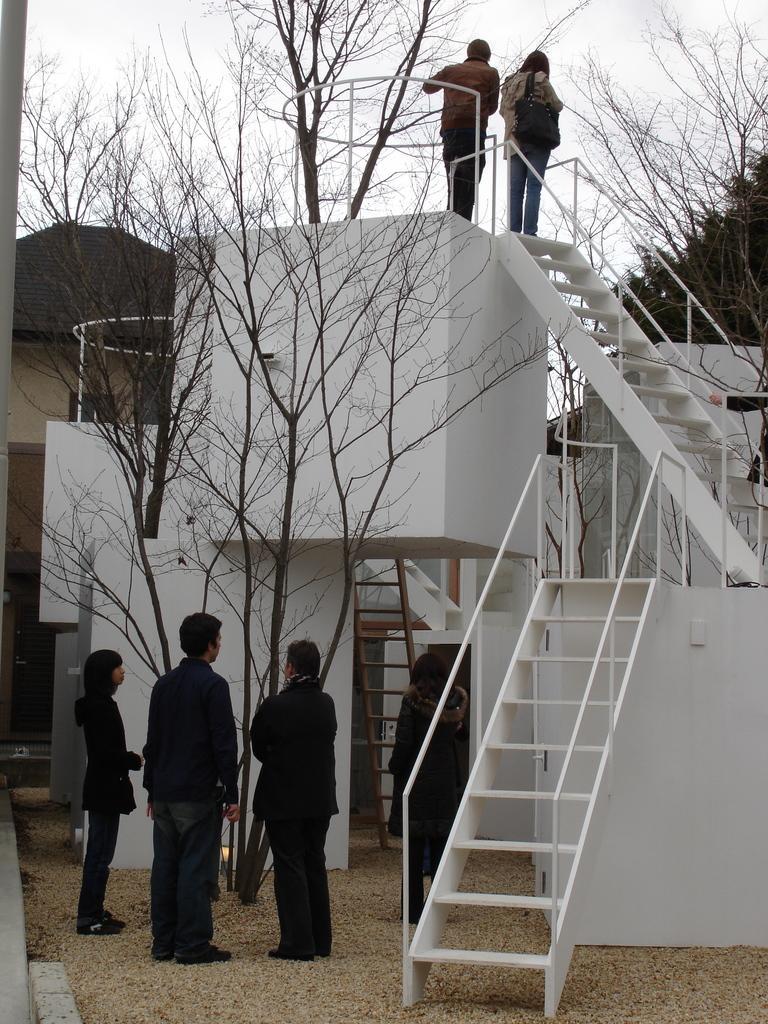Describe this image in one or two sentences. In this picture we can observe stairs. There are some people standing in this picture. There are dried trees. We can observe a house. In the background there is a sky. 